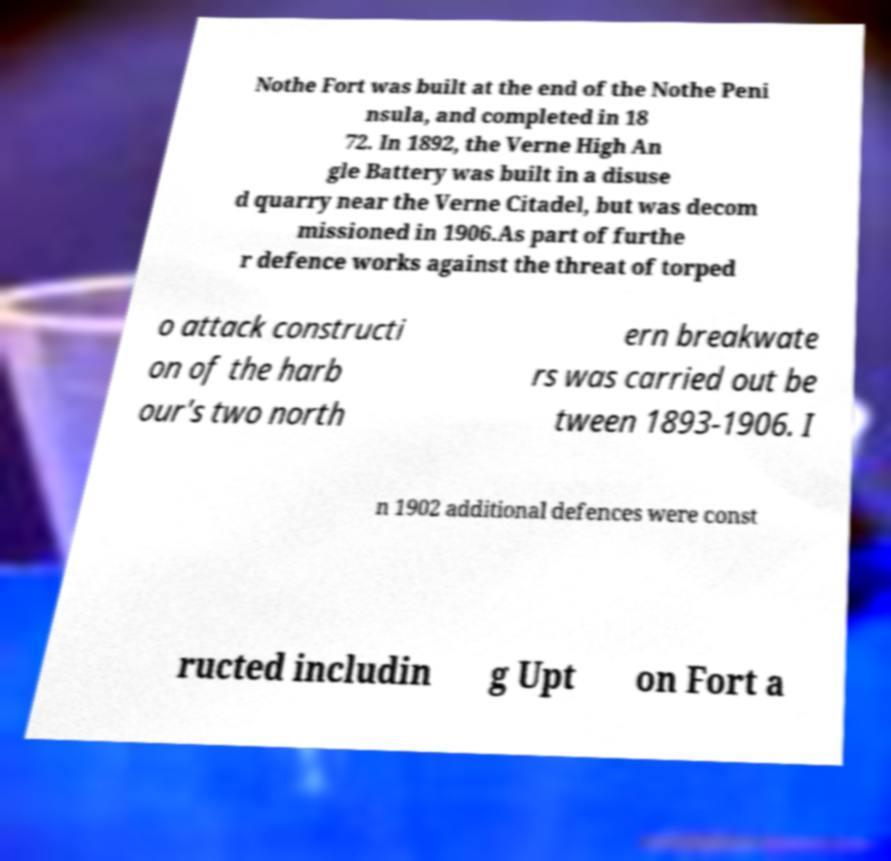Please identify and transcribe the text found in this image. Nothe Fort was built at the end of the Nothe Peni nsula, and completed in 18 72. In 1892, the Verne High An gle Battery was built in a disuse d quarry near the Verne Citadel, but was decom missioned in 1906.As part of furthe r defence works against the threat of torped o attack constructi on of the harb our's two north ern breakwate rs was carried out be tween 1893-1906. I n 1902 additional defences were const ructed includin g Upt on Fort a 